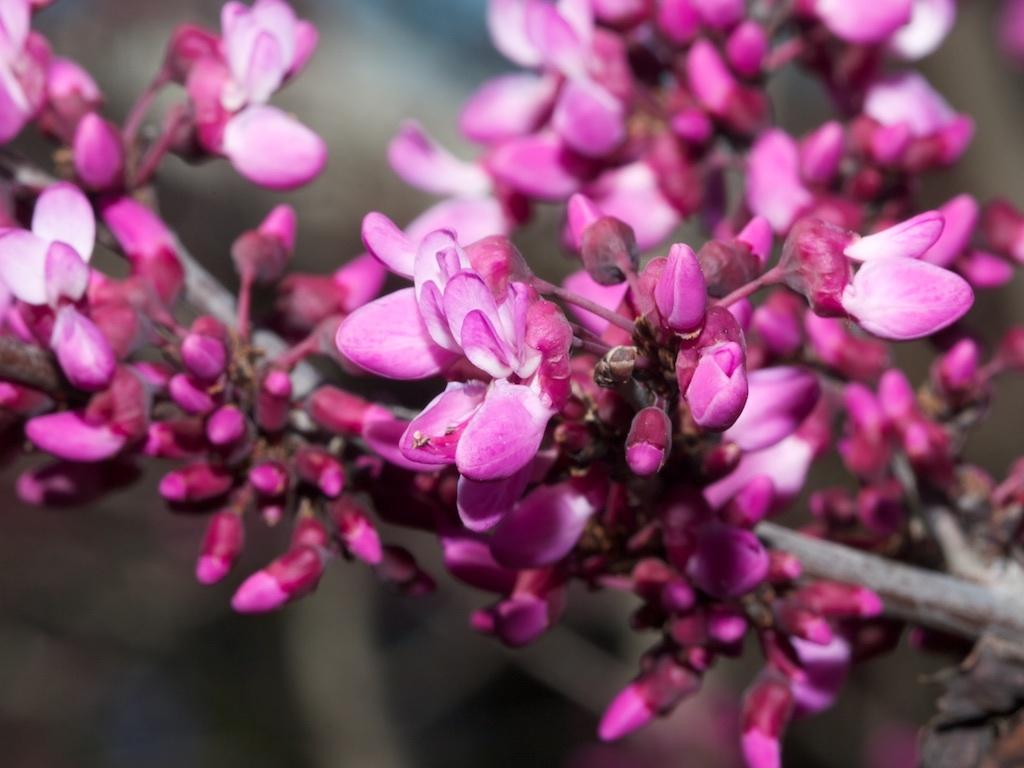What type of flowers are depicted in the image? There are pink buds in the image. Can you describe the background of the image? The background of the image is blurred. What type of pickle can be seen hanging from the thread in the image? There is no pickle or thread present in the image; it only features pink buds and a blurred background. 